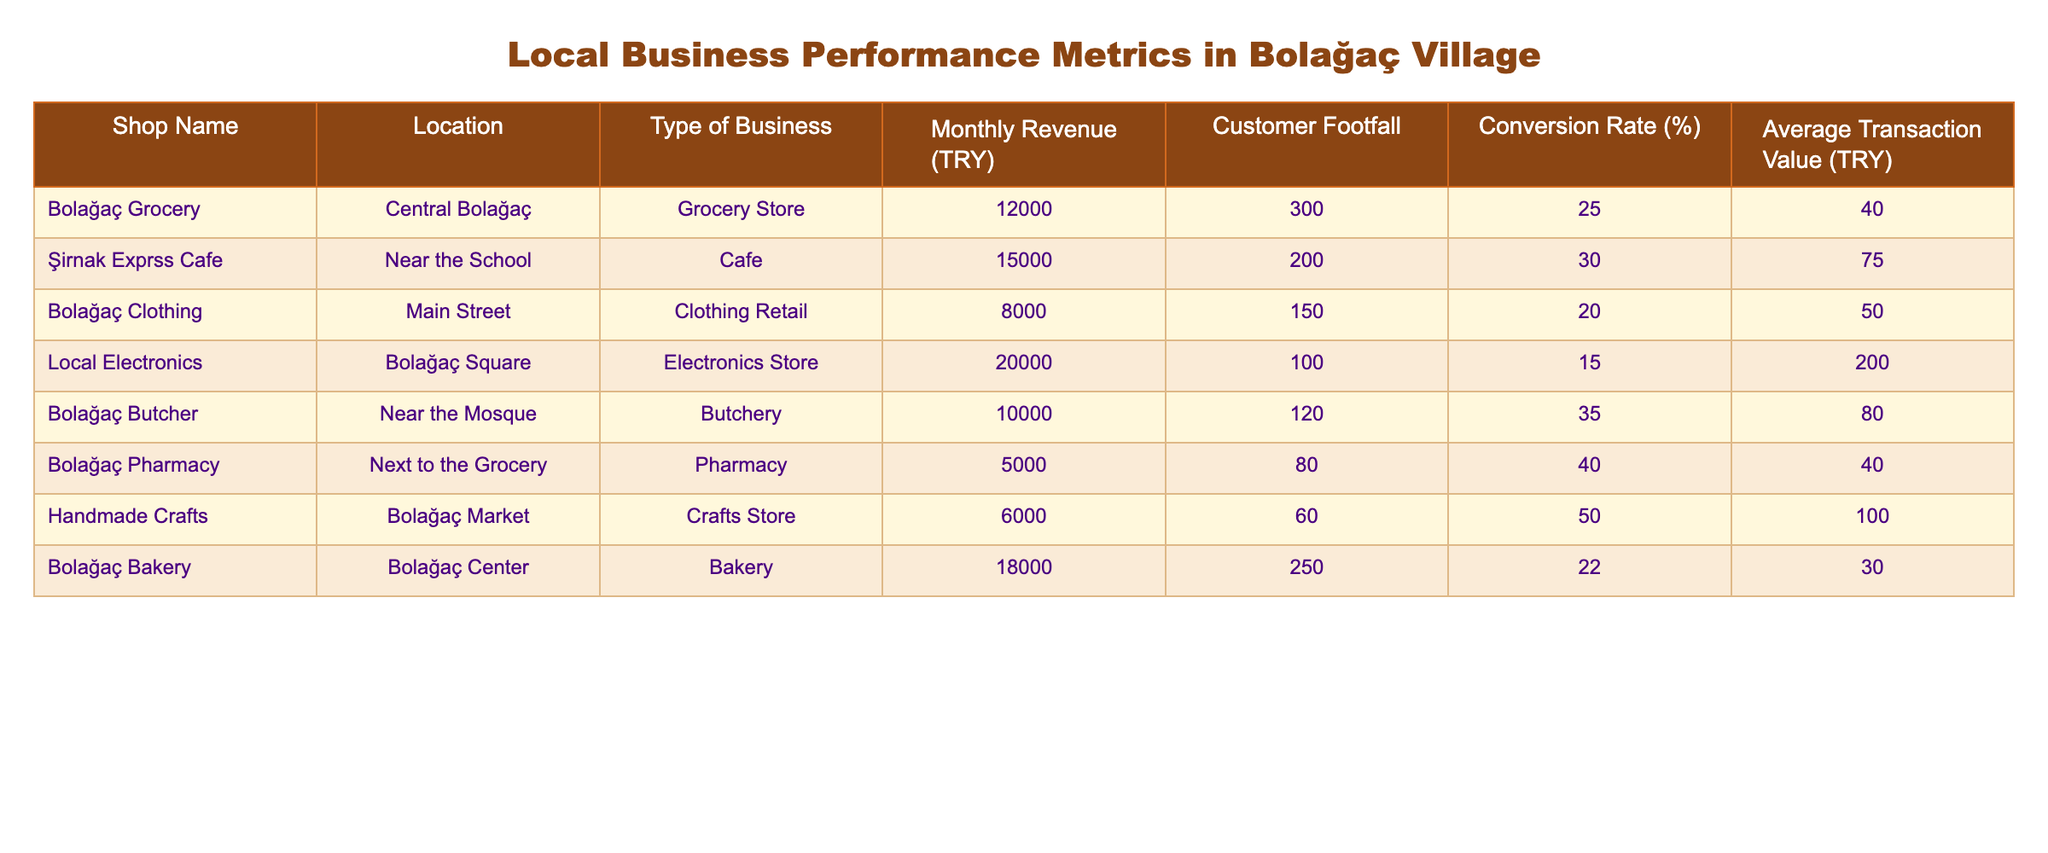What is the monthly revenue of the Bolağaç Butcher? The Bolağaç Butcher's monthly revenue is listed in the table under "Monthly Revenue (TRY)". The relevant value is 10,000 TRY.
Answer: 10,000 TRY Which shop has the highest customer footfall? Looking at the "Customer Footfall" column, I see that the Bolağaç Grocery has 300 customers, which is the highest value in the table.
Answer: Bolağaç Grocery What is the average transaction value of the Şirnak Exprss Cafe? The average transaction value for the Şirnak Exprss Cafe is found in the "Average Transaction Value (TRY)" column, which shows 75 TRY.
Answer: 75 TRY Is the conversion rate of the Local Electronics store greater than 20%? The conversion rate for Local Electronics is 15%. This is less than 20%, which indicates that it is not greater.
Answer: No What is the total monthly revenue of all shops listed in the table? To find the total monthly revenue, I add up the "Monthly Revenue (TRY)" values: 12000 + 15000 + 8000 + 20000 + 10000 + 5000 + 6000 + 18000 = 100000 TRY.
Answer: 100000 TRY Which shop has the highest conversion rate? By reviewing the "Conversion Rate (%)" column, Handmade Crafts has the highest conversion rate at 50%.
Answer: Handmade Crafts Is the average transaction value of the Bolağaç Pharmacy greater than that of the Bolağaç Butcher? The average transaction value for the Bolağaç Pharmacy is 40 TRY, while for the Bolağaç Butcher it is 80 TRY. Since 40 is not greater than 80, the answer is no.
Answer: No What is the total customer footfall for shops in Bolağaç Center and near the Mosque? The Bolağaç Bakery located in Bolağaç Center has a customer footfall of 250 and the Bolağaç Butcher near the Mosque has 120. Adding these two values gives 250 + 120 = 370.
Answer: 370 